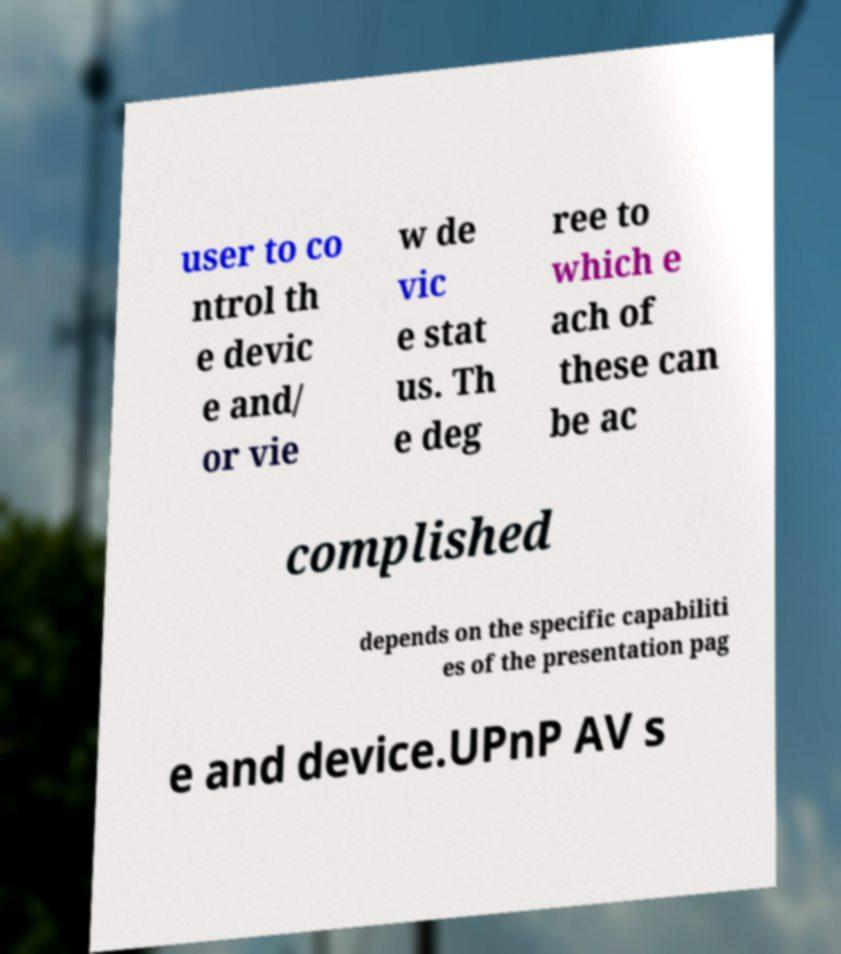Can you accurately transcribe the text from the provided image for me? user to co ntrol th e devic e and/ or vie w de vic e stat us. Th e deg ree to which e ach of these can be ac complished depends on the specific capabiliti es of the presentation pag e and device.UPnP AV s 